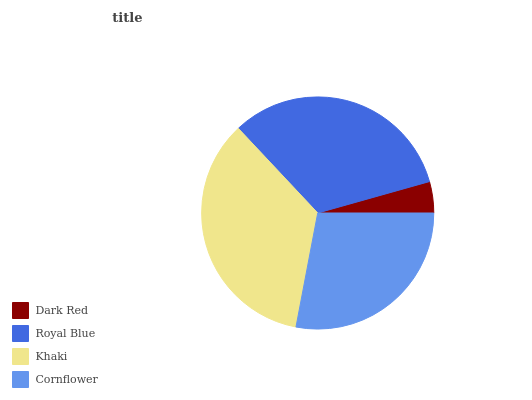Is Dark Red the minimum?
Answer yes or no. Yes. Is Khaki the maximum?
Answer yes or no. Yes. Is Royal Blue the minimum?
Answer yes or no. No. Is Royal Blue the maximum?
Answer yes or no. No. Is Royal Blue greater than Dark Red?
Answer yes or no. Yes. Is Dark Red less than Royal Blue?
Answer yes or no. Yes. Is Dark Red greater than Royal Blue?
Answer yes or no. No. Is Royal Blue less than Dark Red?
Answer yes or no. No. Is Royal Blue the high median?
Answer yes or no. Yes. Is Cornflower the low median?
Answer yes or no. Yes. Is Khaki the high median?
Answer yes or no. No. Is Royal Blue the low median?
Answer yes or no. No. 